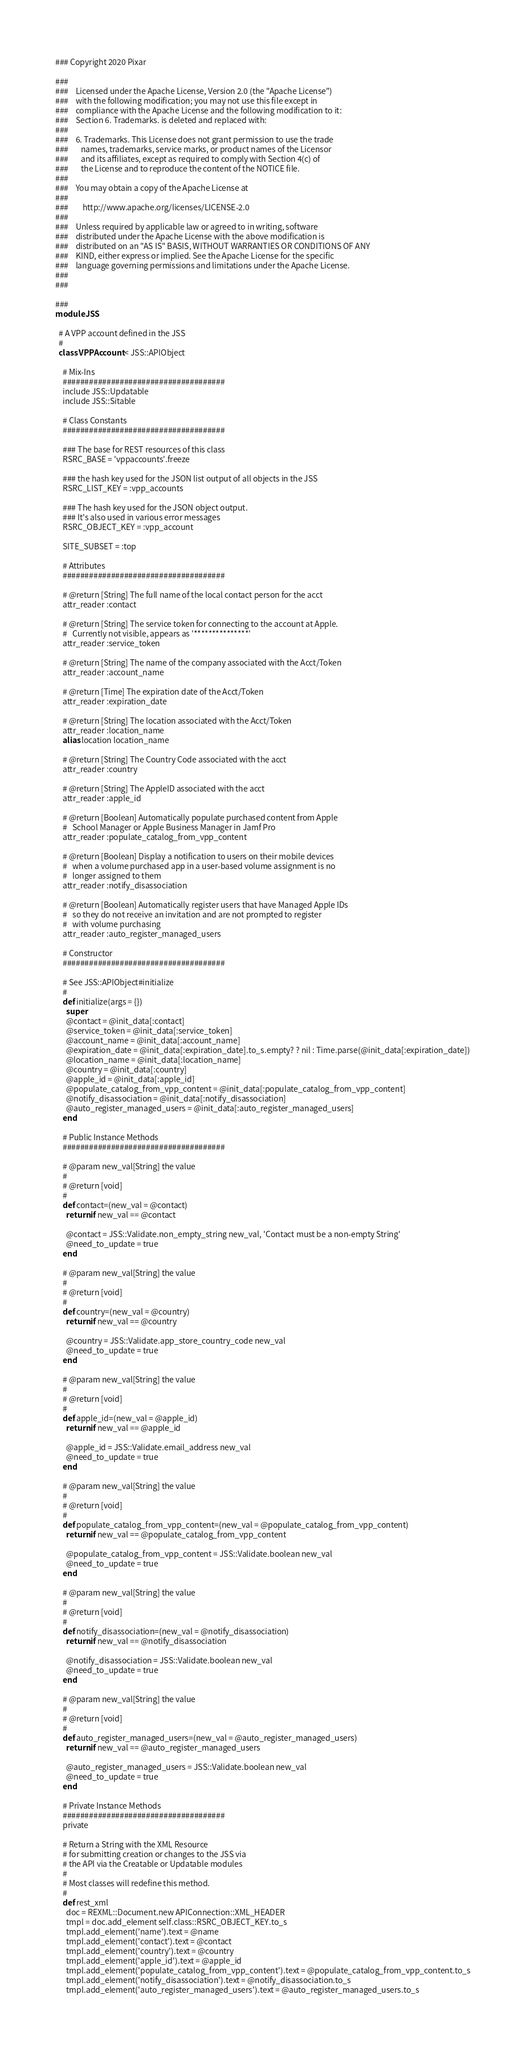Convert code to text. <code><loc_0><loc_0><loc_500><loc_500><_Ruby_>### Copyright 2020 Pixar

###
###    Licensed under the Apache License, Version 2.0 (the "Apache License")
###    with the following modification; you may not use this file except in
###    compliance with the Apache License and the following modification to it:
###    Section 6. Trademarks. is deleted and replaced with:
###
###    6. Trademarks. This License does not grant permission to use the trade
###       names, trademarks, service marks, or product names of the Licensor
###       and its affiliates, except as required to comply with Section 4(c) of
###       the License and to reproduce the content of the NOTICE file.
###
###    You may obtain a copy of the Apache License at
###
###        http://www.apache.org/licenses/LICENSE-2.0
###
###    Unless required by applicable law or agreed to in writing, software
###    distributed under the Apache License with the above modification is
###    distributed on an "AS IS" BASIS, WITHOUT WARRANTIES OR CONDITIONS OF ANY
###    KIND, either express or implied. See the Apache License for the specific
###    language governing permissions and limitations under the Apache License.
###
###

###
module JSS

  # A VPP account defined in the JSS
  #
  class VPPAccount < JSS::APIObject

    # Mix-Ins
    #####################################
    include JSS::Updatable
    include JSS::Sitable

    # Class Constants
    #####################################

    ### The base for REST resources of this class
    RSRC_BASE = 'vppaccounts'.freeze

    ### the hash key used for the JSON list output of all objects in the JSS
    RSRC_LIST_KEY = :vpp_accounts

    ### The hash key used for the JSON object output.
    ### It's also used in various error messages
    RSRC_OBJECT_KEY = :vpp_account

    SITE_SUBSET = :top

    # Attributes
    #####################################

    # @return [String] The full name of the local contact person for the acct
    attr_reader :contact

    # @return [String] The service token for connecting to the account at Apple.
    #   Currently not visible, appears as '***************'
    attr_reader :service_token

    # @return [String] The name of the company associated with the Acct/Token
    attr_reader :account_name

    # @return [Time] The expiration date of the Acct/Token
    attr_reader :expiration_date

    # @return [String] The location associated with the Acct/Token
    attr_reader :location_name
    alias location location_name

    # @return [String] The Country Code associated with the acct
    attr_reader :country

    # @return [String] The AppleID associated with the acct
    attr_reader :apple_id

    # @return [Boolean] Automatically populate purchased content from Apple
    #   School Manager or Apple Business Manager in Jamf Pro
    attr_reader :populate_catalog_from_vpp_content

    # @return [Boolean] Display a notification to users on their mobile devices
    #   when a volume purchased app in a user-based volume assignment is no
    #   longer assigned to them
    attr_reader :notify_disassociation

    # @return [Boolean] Automatically register users that have Managed Apple IDs
    #   so they do not receive an invitation and are not prompted to register
    #   with volume purchasing
    attr_reader :auto_register_managed_users

    # Constructor
    #####################################

    # See JSS::APIObject#initialize
    #
    def initialize(args = {})
      super
      @contact = @init_data[:contact]
      @service_token = @init_data[:service_token]
      @account_name = @init_data[:account_name]
      @expiration_date = @init_data[:expiration_date].to_s.empty? ? nil : Time.parse(@init_data[:expiration_date])
      @location_name = @init_data[:location_name]
      @country = @init_data[:country]
      @apple_id = @init_data[:apple_id]
      @populate_catalog_from_vpp_content = @init_data[:populate_catalog_from_vpp_content]
      @notify_disassociation = @init_data[:notify_disassociation]
      @auto_register_managed_users = @init_data[:auto_register_managed_users]
    end

    # Public Instance Methods
    #####################################

    # @param new_val[String] the value
    #
    # @return [void]
    #
    def contact=(new_val = @contact)
      return if new_val == @contact

      @contact = JSS::Validate.non_empty_string new_val, 'Contact must be a non-empty String'
      @need_to_update = true
    end

    # @param new_val[String] the value
    #
    # @return [void]
    #
    def country=(new_val = @country)
      return if new_val == @country

      @country = JSS::Validate.app_store_country_code new_val
      @need_to_update = true
    end

    # @param new_val[String] the value
    #
    # @return [void]
    #
    def apple_id=(new_val = @apple_id)
      return if new_val == @apple_id

      @apple_id = JSS::Validate.email_address new_val
      @need_to_update = true
    end

    # @param new_val[String] the value
    #
    # @return [void]
    #
    def populate_catalog_from_vpp_content=(new_val = @populate_catalog_from_vpp_content)
      return if new_val == @populate_catalog_from_vpp_content

      @populate_catalog_from_vpp_content = JSS::Validate.boolean new_val
      @need_to_update = true
    end

    # @param new_val[String] the value
    #
    # @return [void]
    #
    def notify_disassociation=(new_val = @notify_disassociation)
      return if new_val == @notify_disassociation

      @notify_disassociation = JSS::Validate.boolean new_val
      @need_to_update = true
    end

    # @param new_val[String] the value
    #
    # @return [void]
    #
    def auto_register_managed_users=(new_val = @auto_register_managed_users)
      return if new_val == @auto_register_managed_users

      @auto_register_managed_users = JSS::Validate.boolean new_val
      @need_to_update = true
    end

    # Private Instance Methods
    #####################################
    private

    # Return a String with the XML Resource
    # for submitting creation or changes to the JSS via
    # the API via the Creatable or Updatable modules
    #
    # Most classes will redefine this method.
    #
    def rest_xml
      doc = REXML::Document.new APIConnection::XML_HEADER
      tmpl = doc.add_element self.class::RSRC_OBJECT_KEY.to_s
      tmpl.add_element('name').text = @name
      tmpl.add_element('contact').text = @contact
      tmpl.add_element('country').text = @country
      tmpl.add_element('apple_id').text = @apple_id
      tmpl.add_element('populate_catalog_from_vpp_content').text = @populate_catalog_from_vpp_content.to_s
      tmpl.add_element('notify_disassociation').text = @notify_disassociation.to_s
      tmpl.add_element('auto_register_managed_users').text = @auto_register_managed_users.to_s
</code> 